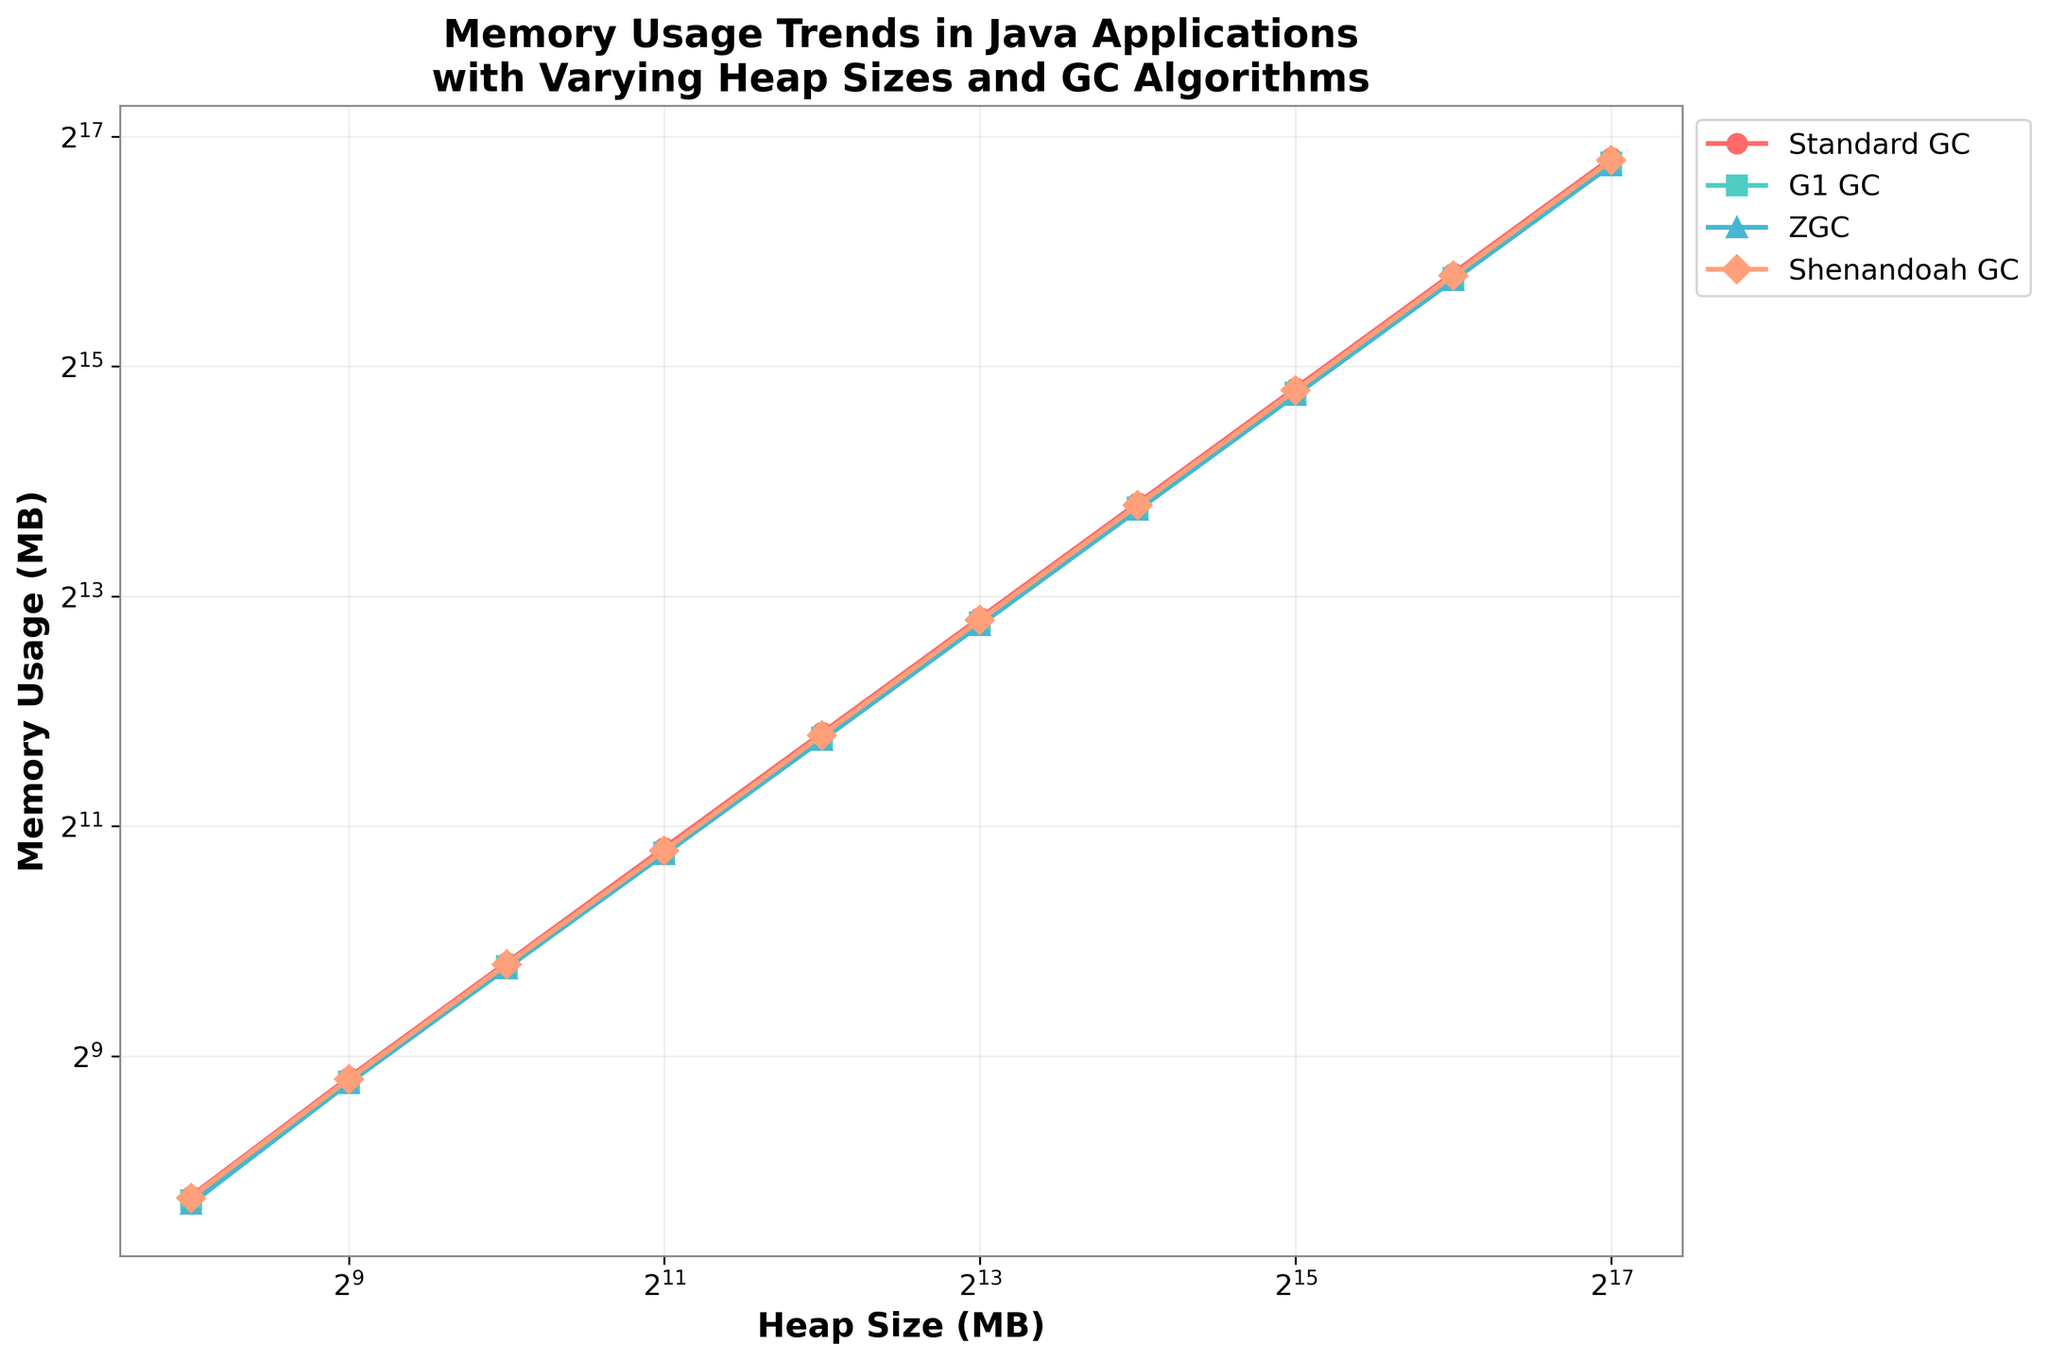What's the memory usage for G1 GC at 4096 MB heap size? Find the point on the G1 GC line (green color) that corresponds to 4096 MB on the x-axis and read the memory usage value on the y-axis.
Answer: 3500 MB Which GC algorithm has the lowest memory usage for a heap size of 8192 MB? Compare the memory usage values for all four GC algorithms at the x-axis value of 8192 MB. ZGC has the lowest value.
Answer: ZGC How much more memory does Standard GC use compared to Shenandoah GC at 16384 MB heap size? Find the memory usage values for Standard GC and Shenandoah GC at 16384 MB and subtract the latter from the former (14400 - 14200).
Answer: 200 MB At which heap size does Standard GC's memory usage first exceed 10000 MB? Locate the point on the Standard GC line where the memory usage crosses 10000 MB on the y-axis. It happens between 8192 MB and 16384 MB.
Answer: 16384 MB What is the average memory usage for ZGC across all heap sizes? Sum up all memory usage values for ZGC and divide by the number of data points: (210 + 435 + 870 + 1730 + 3450 + 6900 + 13800 + 27600 + 55200 + 110400) / 10 = 29756 MB.
Answer: 29756 MB Which GC algorithm shows the most significant increase in memory usage between heap sizes of 256 MB and 512 MB? Calculate the difference in memory usage for each GC algorithm between 256 MB and 512 MB and determine the highest increase. The differences are: Standard GC (450-220=230), G1 GC (440-215=225), ZGC (435-210=225), Shenandoah GC (445-218=227). Standard GC has the highest increase.
Answer: Standard GC Does any GC algorithm consistently use less memory than Standard GC across all heap sizes? Compare each GC algorithm's memory usage to Standard GC across all heap sizes. All other algorithms consistently use less memory than Standard GC.
Answer: Yes, all other GCs How does memory usage for Shenandoah GC change from 1024 MB to 2048 MB heap size? Identify memory usage values at 1024 MB and 2048 MB heap sizes for Shenandoah GC and calculate the difference: 1770 - 890 = 880 MB increase.
Answer: Increases by 880 MB 